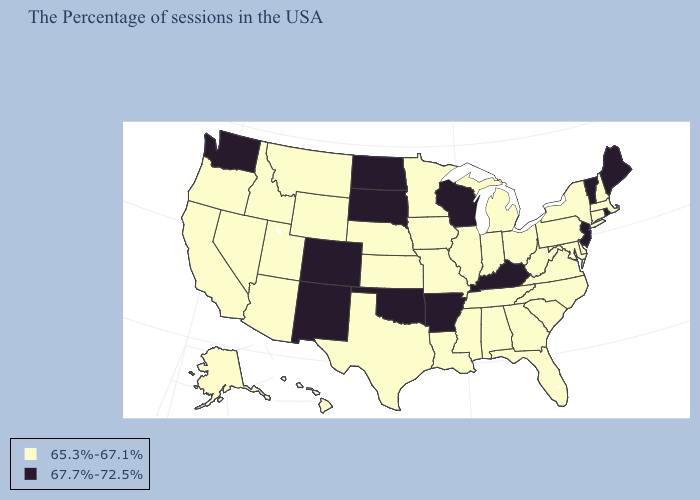Name the states that have a value in the range 65.3%-67.1%?
Give a very brief answer. Massachusetts, New Hampshire, Connecticut, New York, Delaware, Maryland, Pennsylvania, Virginia, North Carolina, South Carolina, West Virginia, Ohio, Florida, Georgia, Michigan, Indiana, Alabama, Tennessee, Illinois, Mississippi, Louisiana, Missouri, Minnesota, Iowa, Kansas, Nebraska, Texas, Wyoming, Utah, Montana, Arizona, Idaho, Nevada, California, Oregon, Alaska, Hawaii. What is the lowest value in the USA?
Quick response, please. 65.3%-67.1%. What is the lowest value in the South?
Quick response, please. 65.3%-67.1%. What is the value of Wyoming?
Keep it brief. 65.3%-67.1%. What is the highest value in the West ?
Answer briefly. 67.7%-72.5%. Does Arkansas have the highest value in the South?
Write a very short answer. Yes. What is the value of New Jersey?
Write a very short answer. 67.7%-72.5%. What is the highest value in the USA?
Keep it brief. 67.7%-72.5%. What is the value of Florida?
Quick response, please. 65.3%-67.1%. Name the states that have a value in the range 65.3%-67.1%?
Concise answer only. Massachusetts, New Hampshire, Connecticut, New York, Delaware, Maryland, Pennsylvania, Virginia, North Carolina, South Carolina, West Virginia, Ohio, Florida, Georgia, Michigan, Indiana, Alabama, Tennessee, Illinois, Mississippi, Louisiana, Missouri, Minnesota, Iowa, Kansas, Nebraska, Texas, Wyoming, Utah, Montana, Arizona, Idaho, Nevada, California, Oregon, Alaska, Hawaii. Does West Virginia have the same value as Rhode Island?
Quick response, please. No. What is the value of New York?
Answer briefly. 65.3%-67.1%. What is the highest value in the USA?
Quick response, please. 67.7%-72.5%. What is the value of Nebraska?
Concise answer only. 65.3%-67.1%. What is the value of Mississippi?
Keep it brief. 65.3%-67.1%. 